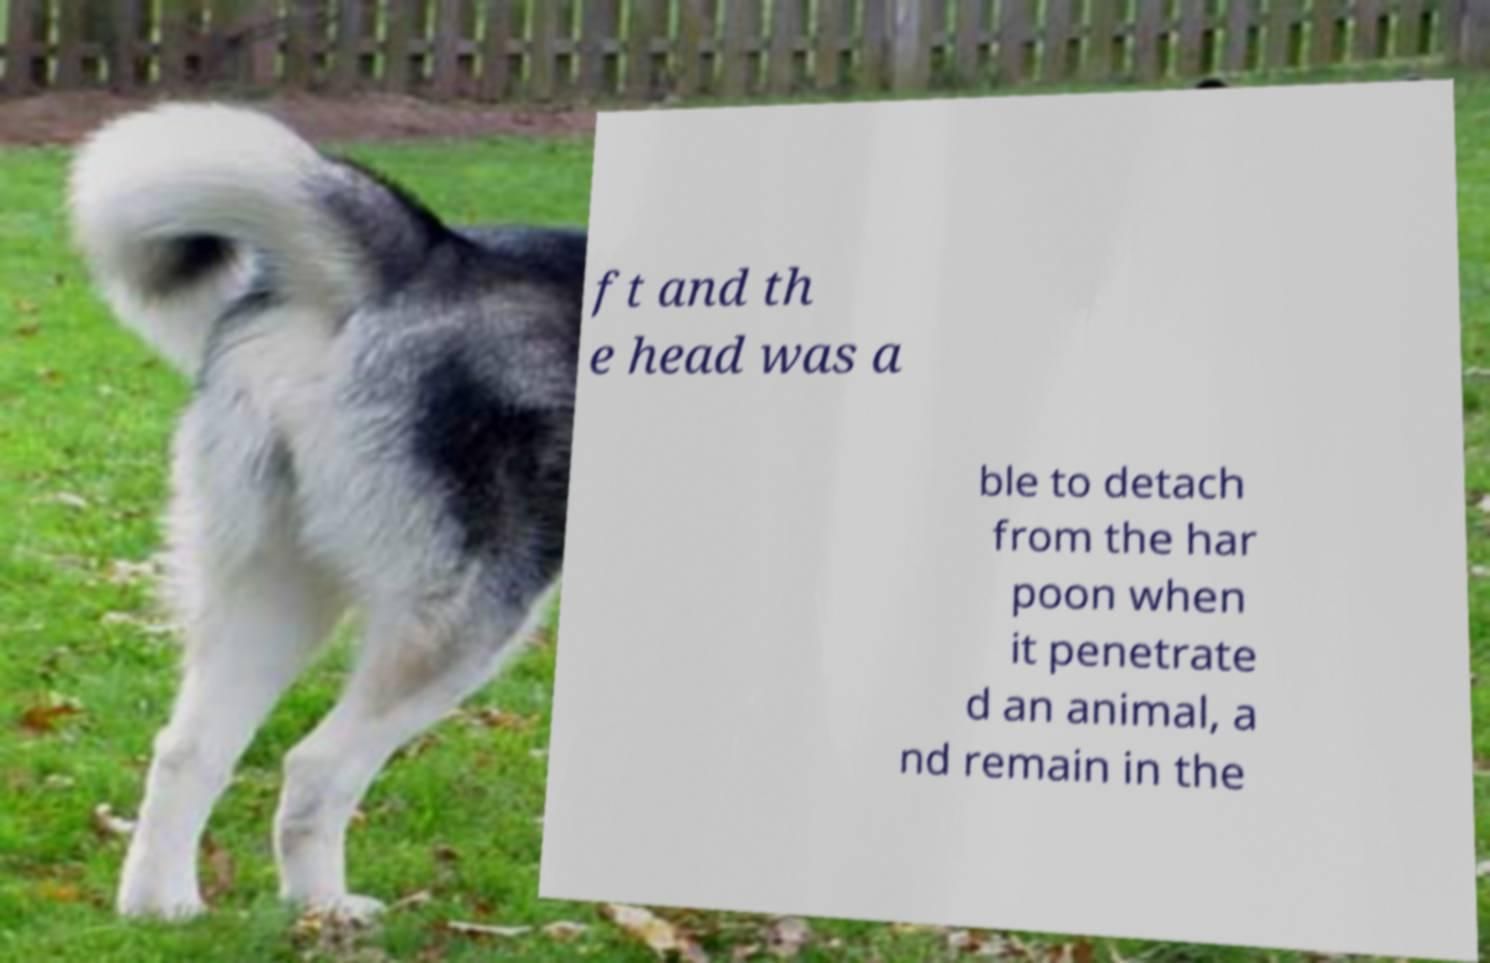Could you extract and type out the text from this image? ft and th e head was a ble to detach from the har poon when it penetrate d an animal, a nd remain in the 